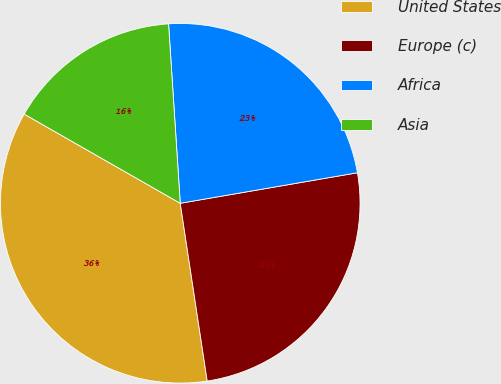Convert chart. <chart><loc_0><loc_0><loc_500><loc_500><pie_chart><fcel>United States<fcel>Europe (c)<fcel>Africa<fcel>Asia<nl><fcel>35.66%<fcel>25.32%<fcel>23.32%<fcel>15.7%<nl></chart> 